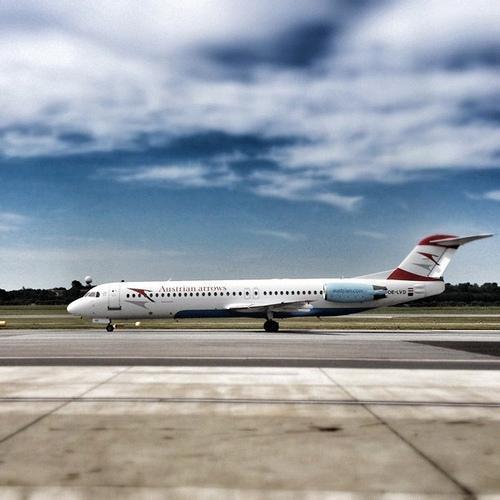How many airplanes do you see?
Give a very brief answer. 1. How many green planes are there?
Give a very brief answer. 0. 